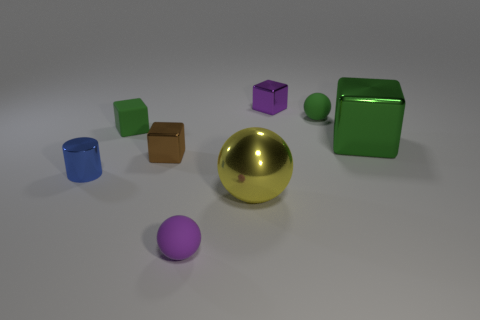There is a rubber object that is the same shape as the brown metallic object; what size is it?
Provide a short and direct response. Small. Does the big green shiny object have the same shape as the brown thing?
Give a very brief answer. Yes. Are there fewer metal blocks left of the large green object than big yellow things?
Your response must be concise. No. The green rubber thing to the right of the big yellow ball has what shape?
Ensure brevity in your answer.  Sphere. Is the size of the yellow sphere the same as the metallic thing left of the tiny green rubber block?
Your answer should be compact. No. Are there any large green cubes made of the same material as the large sphere?
Your answer should be compact. Yes. How many cubes are either tiny matte objects or yellow things?
Offer a very short reply. 1. Are there any metallic objects that are right of the purple thing that is in front of the tiny purple block?
Your answer should be compact. Yes. Are there fewer cyan shiny things than big yellow spheres?
Provide a succinct answer. Yes. What number of other tiny blue objects are the same shape as the blue object?
Offer a very short reply. 0. 